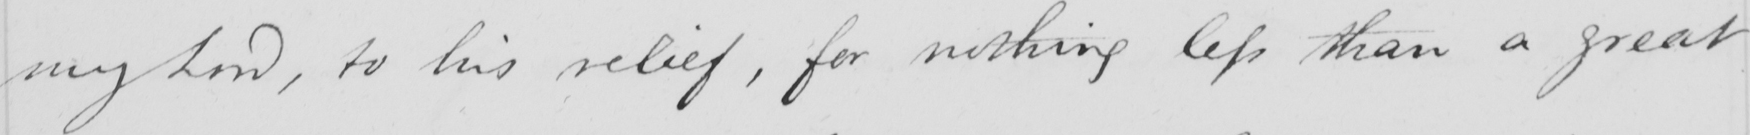Please provide the text content of this handwritten line. my Lord , to his relief , for nothing less than a great 